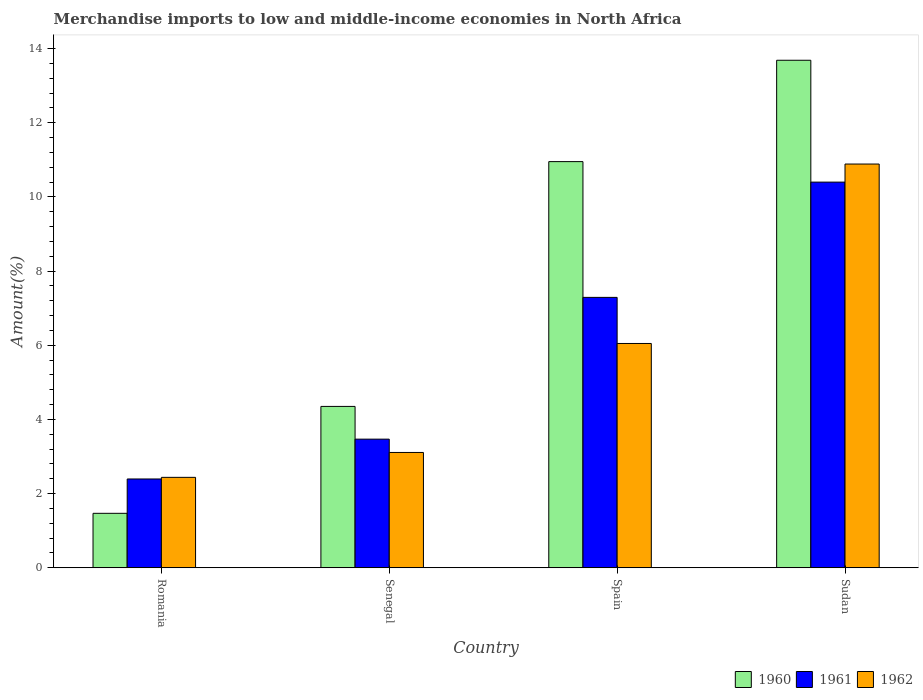How many different coloured bars are there?
Provide a succinct answer. 3. How many bars are there on the 2nd tick from the left?
Give a very brief answer. 3. How many bars are there on the 4th tick from the right?
Provide a succinct answer. 3. What is the label of the 2nd group of bars from the left?
Your response must be concise. Senegal. What is the percentage of amount earned from merchandise imports in 1961 in Spain?
Offer a very short reply. 7.29. Across all countries, what is the maximum percentage of amount earned from merchandise imports in 1960?
Make the answer very short. 13.68. Across all countries, what is the minimum percentage of amount earned from merchandise imports in 1961?
Provide a short and direct response. 2.39. In which country was the percentage of amount earned from merchandise imports in 1961 maximum?
Provide a succinct answer. Sudan. In which country was the percentage of amount earned from merchandise imports in 1960 minimum?
Offer a terse response. Romania. What is the total percentage of amount earned from merchandise imports in 1960 in the graph?
Ensure brevity in your answer.  30.45. What is the difference between the percentage of amount earned from merchandise imports in 1960 in Senegal and that in Sudan?
Your response must be concise. -9.33. What is the difference between the percentage of amount earned from merchandise imports in 1962 in Sudan and the percentage of amount earned from merchandise imports in 1961 in Romania?
Provide a short and direct response. 8.49. What is the average percentage of amount earned from merchandise imports in 1961 per country?
Ensure brevity in your answer.  5.89. What is the difference between the percentage of amount earned from merchandise imports of/in 1961 and percentage of amount earned from merchandise imports of/in 1960 in Romania?
Provide a short and direct response. 0.93. In how many countries, is the percentage of amount earned from merchandise imports in 1960 greater than 4 %?
Keep it short and to the point. 3. What is the ratio of the percentage of amount earned from merchandise imports in 1960 in Senegal to that in Sudan?
Ensure brevity in your answer.  0.32. Is the percentage of amount earned from merchandise imports in 1962 in Senegal less than that in Sudan?
Your answer should be compact. Yes. What is the difference between the highest and the second highest percentage of amount earned from merchandise imports in 1960?
Give a very brief answer. 6.6. What is the difference between the highest and the lowest percentage of amount earned from merchandise imports in 1960?
Make the answer very short. 12.22. Is the sum of the percentage of amount earned from merchandise imports in 1960 in Romania and Sudan greater than the maximum percentage of amount earned from merchandise imports in 1962 across all countries?
Your answer should be very brief. Yes. How many countries are there in the graph?
Offer a very short reply. 4. Are the values on the major ticks of Y-axis written in scientific E-notation?
Your response must be concise. No. Does the graph contain any zero values?
Offer a terse response. No. Where does the legend appear in the graph?
Provide a succinct answer. Bottom right. How are the legend labels stacked?
Offer a terse response. Horizontal. What is the title of the graph?
Offer a very short reply. Merchandise imports to low and middle-income economies in North Africa. What is the label or title of the Y-axis?
Ensure brevity in your answer.  Amount(%). What is the Amount(%) of 1960 in Romania?
Offer a terse response. 1.47. What is the Amount(%) of 1961 in Romania?
Your answer should be very brief. 2.39. What is the Amount(%) of 1962 in Romania?
Your answer should be compact. 2.44. What is the Amount(%) in 1960 in Senegal?
Your answer should be very brief. 4.35. What is the Amount(%) in 1961 in Senegal?
Offer a very short reply. 3.47. What is the Amount(%) of 1962 in Senegal?
Offer a very short reply. 3.11. What is the Amount(%) of 1960 in Spain?
Your answer should be very brief. 10.95. What is the Amount(%) in 1961 in Spain?
Your answer should be very brief. 7.29. What is the Amount(%) in 1962 in Spain?
Provide a short and direct response. 6.05. What is the Amount(%) of 1960 in Sudan?
Ensure brevity in your answer.  13.68. What is the Amount(%) of 1961 in Sudan?
Offer a very short reply. 10.4. What is the Amount(%) in 1962 in Sudan?
Your response must be concise. 10.89. Across all countries, what is the maximum Amount(%) in 1960?
Make the answer very short. 13.68. Across all countries, what is the maximum Amount(%) in 1961?
Offer a very short reply. 10.4. Across all countries, what is the maximum Amount(%) in 1962?
Provide a succinct answer. 10.89. Across all countries, what is the minimum Amount(%) of 1960?
Make the answer very short. 1.47. Across all countries, what is the minimum Amount(%) in 1961?
Your answer should be very brief. 2.39. Across all countries, what is the minimum Amount(%) in 1962?
Your response must be concise. 2.44. What is the total Amount(%) of 1960 in the graph?
Offer a very short reply. 30.45. What is the total Amount(%) in 1961 in the graph?
Provide a succinct answer. 23.55. What is the total Amount(%) of 1962 in the graph?
Your answer should be compact. 22.48. What is the difference between the Amount(%) in 1960 in Romania and that in Senegal?
Make the answer very short. -2.88. What is the difference between the Amount(%) in 1961 in Romania and that in Senegal?
Provide a succinct answer. -1.07. What is the difference between the Amount(%) in 1962 in Romania and that in Senegal?
Offer a very short reply. -0.67. What is the difference between the Amount(%) in 1960 in Romania and that in Spain?
Keep it short and to the point. -9.48. What is the difference between the Amount(%) of 1961 in Romania and that in Spain?
Offer a terse response. -4.9. What is the difference between the Amount(%) of 1962 in Romania and that in Spain?
Your response must be concise. -3.61. What is the difference between the Amount(%) in 1960 in Romania and that in Sudan?
Make the answer very short. -12.22. What is the difference between the Amount(%) of 1961 in Romania and that in Sudan?
Keep it short and to the point. -8. What is the difference between the Amount(%) in 1962 in Romania and that in Sudan?
Ensure brevity in your answer.  -8.45. What is the difference between the Amount(%) of 1960 in Senegal and that in Spain?
Your answer should be compact. -6.6. What is the difference between the Amount(%) of 1961 in Senegal and that in Spain?
Your answer should be very brief. -3.82. What is the difference between the Amount(%) of 1962 in Senegal and that in Spain?
Keep it short and to the point. -2.94. What is the difference between the Amount(%) in 1960 in Senegal and that in Sudan?
Keep it short and to the point. -9.33. What is the difference between the Amount(%) in 1961 in Senegal and that in Sudan?
Offer a terse response. -6.93. What is the difference between the Amount(%) in 1962 in Senegal and that in Sudan?
Offer a terse response. -7.78. What is the difference between the Amount(%) of 1960 in Spain and that in Sudan?
Provide a short and direct response. -2.73. What is the difference between the Amount(%) in 1961 in Spain and that in Sudan?
Keep it short and to the point. -3.11. What is the difference between the Amount(%) in 1962 in Spain and that in Sudan?
Offer a terse response. -4.84. What is the difference between the Amount(%) of 1960 in Romania and the Amount(%) of 1961 in Senegal?
Give a very brief answer. -2. What is the difference between the Amount(%) in 1960 in Romania and the Amount(%) in 1962 in Senegal?
Provide a short and direct response. -1.64. What is the difference between the Amount(%) in 1961 in Romania and the Amount(%) in 1962 in Senegal?
Give a very brief answer. -0.71. What is the difference between the Amount(%) in 1960 in Romania and the Amount(%) in 1961 in Spain?
Keep it short and to the point. -5.82. What is the difference between the Amount(%) in 1960 in Romania and the Amount(%) in 1962 in Spain?
Ensure brevity in your answer.  -4.58. What is the difference between the Amount(%) in 1961 in Romania and the Amount(%) in 1962 in Spain?
Give a very brief answer. -3.65. What is the difference between the Amount(%) in 1960 in Romania and the Amount(%) in 1961 in Sudan?
Provide a short and direct response. -8.93. What is the difference between the Amount(%) in 1960 in Romania and the Amount(%) in 1962 in Sudan?
Provide a short and direct response. -9.42. What is the difference between the Amount(%) of 1961 in Romania and the Amount(%) of 1962 in Sudan?
Keep it short and to the point. -8.49. What is the difference between the Amount(%) in 1960 in Senegal and the Amount(%) in 1961 in Spain?
Keep it short and to the point. -2.94. What is the difference between the Amount(%) in 1960 in Senegal and the Amount(%) in 1962 in Spain?
Provide a short and direct response. -1.7. What is the difference between the Amount(%) of 1961 in Senegal and the Amount(%) of 1962 in Spain?
Offer a terse response. -2.58. What is the difference between the Amount(%) in 1960 in Senegal and the Amount(%) in 1961 in Sudan?
Keep it short and to the point. -6.05. What is the difference between the Amount(%) of 1960 in Senegal and the Amount(%) of 1962 in Sudan?
Offer a very short reply. -6.54. What is the difference between the Amount(%) of 1961 in Senegal and the Amount(%) of 1962 in Sudan?
Give a very brief answer. -7.42. What is the difference between the Amount(%) of 1960 in Spain and the Amount(%) of 1961 in Sudan?
Your answer should be very brief. 0.55. What is the difference between the Amount(%) of 1960 in Spain and the Amount(%) of 1962 in Sudan?
Keep it short and to the point. 0.07. What is the difference between the Amount(%) of 1961 in Spain and the Amount(%) of 1962 in Sudan?
Offer a terse response. -3.6. What is the average Amount(%) of 1960 per country?
Keep it short and to the point. 7.61. What is the average Amount(%) of 1961 per country?
Keep it short and to the point. 5.89. What is the average Amount(%) of 1962 per country?
Your answer should be very brief. 5.62. What is the difference between the Amount(%) in 1960 and Amount(%) in 1961 in Romania?
Your answer should be compact. -0.93. What is the difference between the Amount(%) in 1960 and Amount(%) in 1962 in Romania?
Make the answer very short. -0.97. What is the difference between the Amount(%) in 1961 and Amount(%) in 1962 in Romania?
Offer a terse response. -0.04. What is the difference between the Amount(%) in 1960 and Amount(%) in 1961 in Senegal?
Ensure brevity in your answer.  0.88. What is the difference between the Amount(%) in 1960 and Amount(%) in 1962 in Senegal?
Provide a succinct answer. 1.24. What is the difference between the Amount(%) of 1961 and Amount(%) of 1962 in Senegal?
Your answer should be compact. 0.36. What is the difference between the Amount(%) in 1960 and Amount(%) in 1961 in Spain?
Ensure brevity in your answer.  3.66. What is the difference between the Amount(%) of 1960 and Amount(%) of 1962 in Spain?
Offer a terse response. 4.9. What is the difference between the Amount(%) of 1961 and Amount(%) of 1962 in Spain?
Your answer should be compact. 1.24. What is the difference between the Amount(%) in 1960 and Amount(%) in 1961 in Sudan?
Your response must be concise. 3.29. What is the difference between the Amount(%) in 1960 and Amount(%) in 1962 in Sudan?
Offer a terse response. 2.8. What is the difference between the Amount(%) of 1961 and Amount(%) of 1962 in Sudan?
Give a very brief answer. -0.49. What is the ratio of the Amount(%) in 1960 in Romania to that in Senegal?
Provide a succinct answer. 0.34. What is the ratio of the Amount(%) of 1961 in Romania to that in Senegal?
Provide a short and direct response. 0.69. What is the ratio of the Amount(%) in 1962 in Romania to that in Senegal?
Offer a very short reply. 0.78. What is the ratio of the Amount(%) of 1960 in Romania to that in Spain?
Keep it short and to the point. 0.13. What is the ratio of the Amount(%) in 1961 in Romania to that in Spain?
Provide a short and direct response. 0.33. What is the ratio of the Amount(%) of 1962 in Romania to that in Spain?
Offer a terse response. 0.4. What is the ratio of the Amount(%) of 1960 in Romania to that in Sudan?
Provide a succinct answer. 0.11. What is the ratio of the Amount(%) of 1961 in Romania to that in Sudan?
Provide a short and direct response. 0.23. What is the ratio of the Amount(%) of 1962 in Romania to that in Sudan?
Give a very brief answer. 0.22. What is the ratio of the Amount(%) of 1960 in Senegal to that in Spain?
Keep it short and to the point. 0.4. What is the ratio of the Amount(%) of 1961 in Senegal to that in Spain?
Offer a very short reply. 0.48. What is the ratio of the Amount(%) in 1962 in Senegal to that in Spain?
Offer a terse response. 0.51. What is the ratio of the Amount(%) of 1960 in Senegal to that in Sudan?
Your answer should be compact. 0.32. What is the ratio of the Amount(%) of 1961 in Senegal to that in Sudan?
Provide a short and direct response. 0.33. What is the ratio of the Amount(%) in 1962 in Senegal to that in Sudan?
Offer a very short reply. 0.29. What is the ratio of the Amount(%) of 1960 in Spain to that in Sudan?
Give a very brief answer. 0.8. What is the ratio of the Amount(%) of 1961 in Spain to that in Sudan?
Provide a short and direct response. 0.7. What is the ratio of the Amount(%) of 1962 in Spain to that in Sudan?
Provide a short and direct response. 0.56. What is the difference between the highest and the second highest Amount(%) in 1960?
Ensure brevity in your answer.  2.73. What is the difference between the highest and the second highest Amount(%) of 1961?
Give a very brief answer. 3.11. What is the difference between the highest and the second highest Amount(%) of 1962?
Make the answer very short. 4.84. What is the difference between the highest and the lowest Amount(%) in 1960?
Offer a very short reply. 12.22. What is the difference between the highest and the lowest Amount(%) of 1961?
Ensure brevity in your answer.  8. What is the difference between the highest and the lowest Amount(%) of 1962?
Provide a short and direct response. 8.45. 